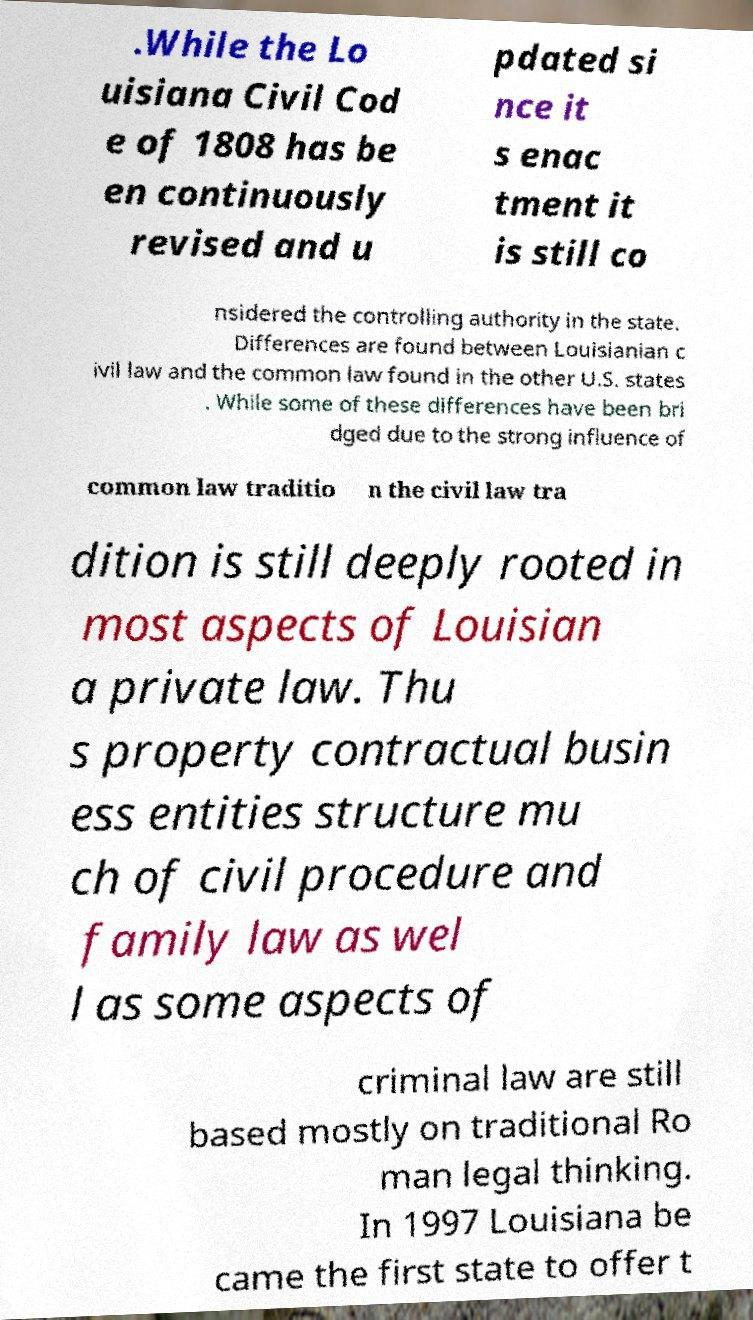Please identify and transcribe the text found in this image. .While the Lo uisiana Civil Cod e of 1808 has be en continuously revised and u pdated si nce it s enac tment it is still co nsidered the controlling authority in the state. Differences are found between Louisianian c ivil law and the common law found in the other U.S. states . While some of these differences have been bri dged due to the strong influence of common law traditio n the civil law tra dition is still deeply rooted in most aspects of Louisian a private law. Thu s property contractual busin ess entities structure mu ch of civil procedure and family law as wel l as some aspects of criminal law are still based mostly on traditional Ro man legal thinking. In 1997 Louisiana be came the first state to offer t 